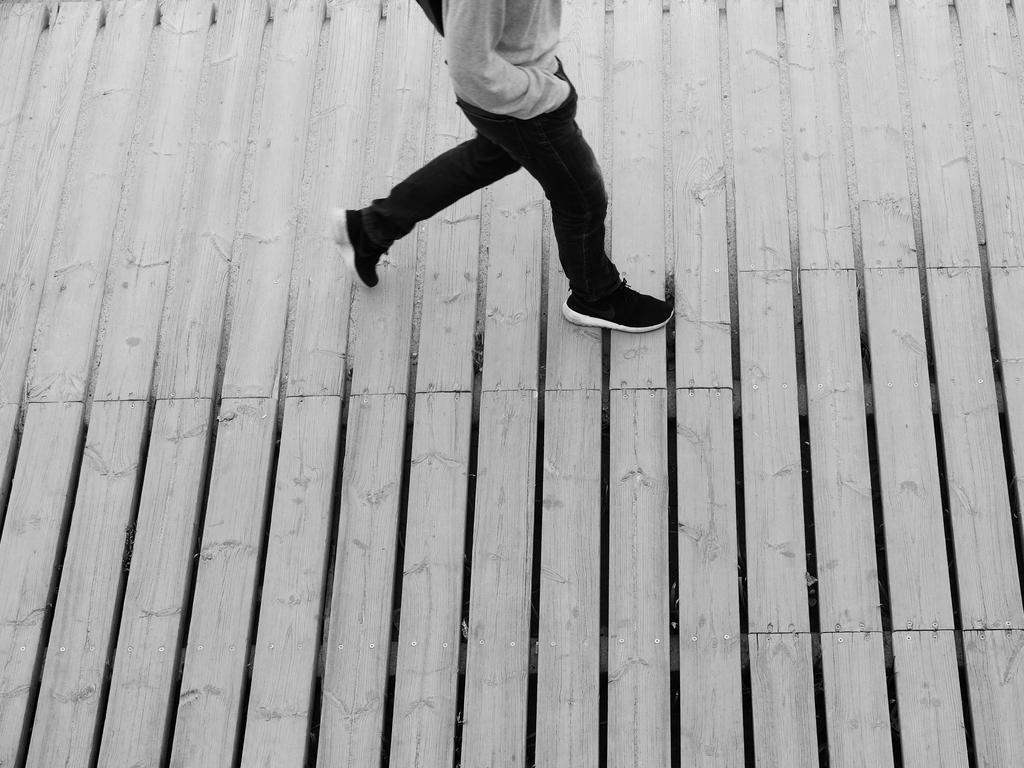What is the color scheme of the image? The image is black and white. Can you describe the person in the image? The person is wearing a t-shirt, jeans, and shoes. What is the person doing in the image? The person is walking on a wooden plank. What type of carpenter tools can be seen in the hands of the monkey in the image? There is no monkey or carpenter tools present in the image. How many bikes are visible in the image? There are no bikes visible in the image. 